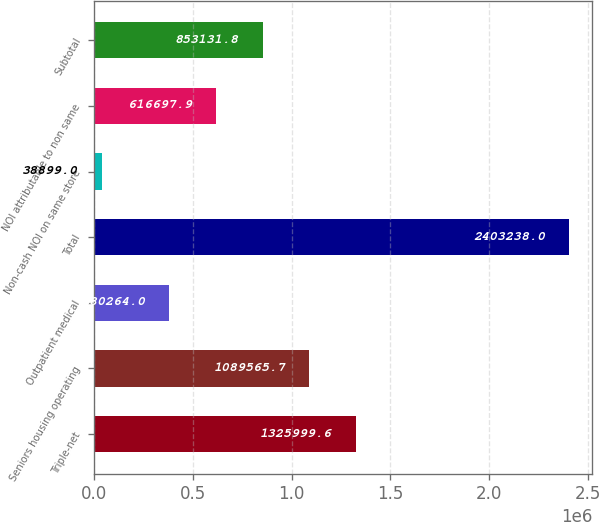Convert chart. <chart><loc_0><loc_0><loc_500><loc_500><bar_chart><fcel>Triple-net<fcel>Seniors housing operating<fcel>Outpatient medical<fcel>Total<fcel>Non-cash NOI on same store<fcel>NOI attributable to non same<fcel>Subtotal<nl><fcel>1.326e+06<fcel>1.08957e+06<fcel>380264<fcel>2.40324e+06<fcel>38899<fcel>616698<fcel>853132<nl></chart> 